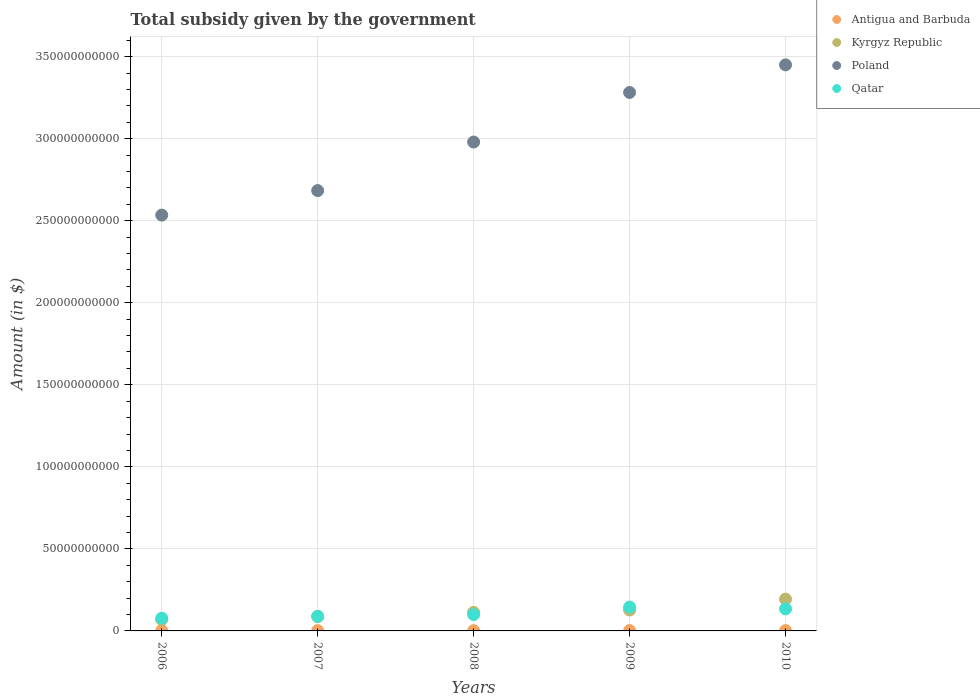How many different coloured dotlines are there?
Your answer should be very brief. 4. Is the number of dotlines equal to the number of legend labels?
Ensure brevity in your answer.  Yes. What is the total revenue collected by the government in Qatar in 2009?
Your answer should be very brief. 1.45e+1. Across all years, what is the maximum total revenue collected by the government in Kyrgyz Republic?
Give a very brief answer. 1.94e+1. Across all years, what is the minimum total revenue collected by the government in Antigua and Barbuda?
Provide a short and direct response. 1.78e+08. In which year was the total revenue collected by the government in Poland maximum?
Your response must be concise. 2010. In which year was the total revenue collected by the government in Qatar minimum?
Provide a succinct answer. 2006. What is the total total revenue collected by the government in Qatar in the graph?
Make the answer very short. 5.46e+1. What is the difference between the total revenue collected by the government in Antigua and Barbuda in 2006 and that in 2010?
Your answer should be compact. -1.39e+07. What is the difference between the total revenue collected by the government in Qatar in 2007 and the total revenue collected by the government in Kyrgyz Republic in 2010?
Make the answer very short. -1.05e+1. What is the average total revenue collected by the government in Qatar per year?
Your answer should be very brief. 1.09e+1. In the year 2009, what is the difference between the total revenue collected by the government in Poland and total revenue collected by the government in Qatar?
Your answer should be very brief. 3.14e+11. In how many years, is the total revenue collected by the government in Kyrgyz Republic greater than 350000000000 $?
Offer a terse response. 0. What is the ratio of the total revenue collected by the government in Antigua and Barbuda in 2006 to that in 2007?
Keep it short and to the point. 1.02. What is the difference between the highest and the second highest total revenue collected by the government in Antigua and Barbuda?
Keep it short and to the point. 1.89e+07. What is the difference between the highest and the lowest total revenue collected by the government in Kyrgyz Republic?
Offer a very short reply. 1.24e+1. Is it the case that in every year, the sum of the total revenue collected by the government in Antigua and Barbuda and total revenue collected by the government in Kyrgyz Republic  is greater than the sum of total revenue collected by the government in Qatar and total revenue collected by the government in Poland?
Your response must be concise. No. Does the total revenue collected by the government in Antigua and Barbuda monotonically increase over the years?
Your response must be concise. No. Is the total revenue collected by the government in Qatar strictly greater than the total revenue collected by the government in Poland over the years?
Keep it short and to the point. No. Is the total revenue collected by the government in Antigua and Barbuda strictly less than the total revenue collected by the government in Qatar over the years?
Offer a very short reply. Yes. How many dotlines are there?
Offer a terse response. 4. What is the difference between two consecutive major ticks on the Y-axis?
Give a very brief answer. 5.00e+1. Where does the legend appear in the graph?
Ensure brevity in your answer.  Top right. How many legend labels are there?
Ensure brevity in your answer.  4. What is the title of the graph?
Give a very brief answer. Total subsidy given by the government. Does "Slovenia" appear as one of the legend labels in the graph?
Make the answer very short. No. What is the label or title of the Y-axis?
Your answer should be very brief. Amount (in $). What is the Amount (in $) in Antigua and Barbuda in 2006?
Your answer should be compact. 1.92e+08. What is the Amount (in $) of Kyrgyz Republic in 2006?
Offer a terse response. 6.97e+09. What is the Amount (in $) in Poland in 2006?
Give a very brief answer. 2.53e+11. What is the Amount (in $) of Qatar in 2006?
Your answer should be very brief. 7.79e+09. What is the Amount (in $) in Antigua and Barbuda in 2007?
Give a very brief answer. 1.88e+08. What is the Amount (in $) of Kyrgyz Republic in 2007?
Your answer should be very brief. 8.72e+09. What is the Amount (in $) in Poland in 2007?
Give a very brief answer. 2.68e+11. What is the Amount (in $) of Qatar in 2007?
Keep it short and to the point. 8.92e+09. What is the Amount (in $) of Antigua and Barbuda in 2008?
Make the answer very short. 1.78e+08. What is the Amount (in $) in Kyrgyz Republic in 2008?
Make the answer very short. 1.13e+1. What is the Amount (in $) of Poland in 2008?
Provide a succinct answer. 2.98e+11. What is the Amount (in $) in Qatar in 2008?
Ensure brevity in your answer.  9.95e+09. What is the Amount (in $) in Antigua and Barbuda in 2009?
Offer a terse response. 2.24e+08. What is the Amount (in $) of Kyrgyz Republic in 2009?
Offer a terse response. 1.28e+1. What is the Amount (in $) in Poland in 2009?
Provide a succinct answer. 3.28e+11. What is the Amount (in $) in Qatar in 2009?
Your response must be concise. 1.45e+1. What is the Amount (in $) in Antigua and Barbuda in 2010?
Ensure brevity in your answer.  2.06e+08. What is the Amount (in $) of Kyrgyz Republic in 2010?
Your answer should be compact. 1.94e+1. What is the Amount (in $) of Poland in 2010?
Make the answer very short. 3.45e+11. What is the Amount (in $) of Qatar in 2010?
Ensure brevity in your answer.  1.34e+1. Across all years, what is the maximum Amount (in $) of Antigua and Barbuda?
Give a very brief answer. 2.24e+08. Across all years, what is the maximum Amount (in $) of Kyrgyz Republic?
Ensure brevity in your answer.  1.94e+1. Across all years, what is the maximum Amount (in $) of Poland?
Offer a terse response. 3.45e+11. Across all years, what is the maximum Amount (in $) of Qatar?
Your response must be concise. 1.45e+1. Across all years, what is the minimum Amount (in $) in Antigua and Barbuda?
Give a very brief answer. 1.78e+08. Across all years, what is the minimum Amount (in $) of Kyrgyz Republic?
Offer a very short reply. 6.97e+09. Across all years, what is the minimum Amount (in $) in Poland?
Keep it short and to the point. 2.53e+11. Across all years, what is the minimum Amount (in $) of Qatar?
Your response must be concise. 7.79e+09. What is the total Amount (in $) in Antigua and Barbuda in the graph?
Ensure brevity in your answer.  9.88e+08. What is the total Amount (in $) in Kyrgyz Republic in the graph?
Provide a succinct answer. 5.91e+1. What is the total Amount (in $) of Poland in the graph?
Your response must be concise. 1.49e+12. What is the total Amount (in $) in Qatar in the graph?
Make the answer very short. 5.46e+1. What is the difference between the Amount (in $) of Antigua and Barbuda in 2006 and that in 2007?
Make the answer very short. 3.10e+06. What is the difference between the Amount (in $) of Kyrgyz Republic in 2006 and that in 2007?
Your answer should be very brief. -1.75e+09. What is the difference between the Amount (in $) of Poland in 2006 and that in 2007?
Provide a short and direct response. -1.49e+1. What is the difference between the Amount (in $) in Qatar in 2006 and that in 2007?
Provide a short and direct response. -1.13e+09. What is the difference between the Amount (in $) in Antigua and Barbuda in 2006 and that in 2008?
Give a very brief answer. 1.32e+07. What is the difference between the Amount (in $) in Kyrgyz Republic in 2006 and that in 2008?
Your answer should be compact. -4.34e+09. What is the difference between the Amount (in $) in Poland in 2006 and that in 2008?
Offer a terse response. -4.45e+1. What is the difference between the Amount (in $) in Qatar in 2006 and that in 2008?
Offer a very short reply. -2.16e+09. What is the difference between the Amount (in $) in Antigua and Barbuda in 2006 and that in 2009?
Your answer should be compact. -3.28e+07. What is the difference between the Amount (in $) in Kyrgyz Republic in 2006 and that in 2009?
Make the answer very short. -5.79e+09. What is the difference between the Amount (in $) of Poland in 2006 and that in 2009?
Ensure brevity in your answer.  -7.47e+1. What is the difference between the Amount (in $) of Qatar in 2006 and that in 2009?
Your response must be concise. -6.75e+09. What is the difference between the Amount (in $) of Antigua and Barbuda in 2006 and that in 2010?
Ensure brevity in your answer.  -1.39e+07. What is the difference between the Amount (in $) of Kyrgyz Republic in 2006 and that in 2010?
Offer a very short reply. -1.24e+1. What is the difference between the Amount (in $) in Poland in 2006 and that in 2010?
Your answer should be very brief. -9.16e+1. What is the difference between the Amount (in $) of Qatar in 2006 and that in 2010?
Make the answer very short. -5.64e+09. What is the difference between the Amount (in $) of Antigua and Barbuda in 2007 and that in 2008?
Your response must be concise. 1.01e+07. What is the difference between the Amount (in $) of Kyrgyz Republic in 2007 and that in 2008?
Ensure brevity in your answer.  -2.58e+09. What is the difference between the Amount (in $) in Poland in 2007 and that in 2008?
Provide a succinct answer. -2.96e+1. What is the difference between the Amount (in $) in Qatar in 2007 and that in 2008?
Your answer should be very brief. -1.03e+09. What is the difference between the Amount (in $) in Antigua and Barbuda in 2007 and that in 2009?
Provide a short and direct response. -3.59e+07. What is the difference between the Amount (in $) in Kyrgyz Republic in 2007 and that in 2009?
Give a very brief answer. -4.04e+09. What is the difference between the Amount (in $) of Poland in 2007 and that in 2009?
Provide a succinct answer. -5.98e+1. What is the difference between the Amount (in $) in Qatar in 2007 and that in 2009?
Your answer should be very brief. -5.62e+09. What is the difference between the Amount (in $) of Antigua and Barbuda in 2007 and that in 2010?
Give a very brief answer. -1.70e+07. What is the difference between the Amount (in $) of Kyrgyz Republic in 2007 and that in 2010?
Your answer should be compact. -1.07e+1. What is the difference between the Amount (in $) of Poland in 2007 and that in 2010?
Offer a very short reply. -7.66e+1. What is the difference between the Amount (in $) in Qatar in 2007 and that in 2010?
Your answer should be very brief. -4.51e+09. What is the difference between the Amount (in $) in Antigua and Barbuda in 2008 and that in 2009?
Provide a short and direct response. -4.60e+07. What is the difference between the Amount (in $) in Kyrgyz Republic in 2008 and that in 2009?
Offer a terse response. -1.46e+09. What is the difference between the Amount (in $) in Poland in 2008 and that in 2009?
Make the answer very short. -3.02e+1. What is the difference between the Amount (in $) in Qatar in 2008 and that in 2009?
Give a very brief answer. -4.59e+09. What is the difference between the Amount (in $) in Antigua and Barbuda in 2008 and that in 2010?
Your answer should be very brief. -2.71e+07. What is the difference between the Amount (in $) of Kyrgyz Republic in 2008 and that in 2010?
Your answer should be very brief. -8.08e+09. What is the difference between the Amount (in $) of Poland in 2008 and that in 2010?
Your response must be concise. -4.70e+1. What is the difference between the Amount (in $) of Qatar in 2008 and that in 2010?
Your response must be concise. -3.48e+09. What is the difference between the Amount (in $) of Antigua and Barbuda in 2009 and that in 2010?
Provide a short and direct response. 1.89e+07. What is the difference between the Amount (in $) of Kyrgyz Republic in 2009 and that in 2010?
Offer a very short reply. -6.62e+09. What is the difference between the Amount (in $) in Poland in 2009 and that in 2010?
Your response must be concise. -1.68e+1. What is the difference between the Amount (in $) in Qatar in 2009 and that in 2010?
Your answer should be very brief. 1.11e+09. What is the difference between the Amount (in $) of Antigua and Barbuda in 2006 and the Amount (in $) of Kyrgyz Republic in 2007?
Offer a very short reply. -8.53e+09. What is the difference between the Amount (in $) in Antigua and Barbuda in 2006 and the Amount (in $) in Poland in 2007?
Ensure brevity in your answer.  -2.68e+11. What is the difference between the Amount (in $) of Antigua and Barbuda in 2006 and the Amount (in $) of Qatar in 2007?
Provide a short and direct response. -8.73e+09. What is the difference between the Amount (in $) of Kyrgyz Republic in 2006 and the Amount (in $) of Poland in 2007?
Your answer should be compact. -2.61e+11. What is the difference between the Amount (in $) of Kyrgyz Republic in 2006 and the Amount (in $) of Qatar in 2007?
Keep it short and to the point. -1.95e+09. What is the difference between the Amount (in $) in Poland in 2006 and the Amount (in $) in Qatar in 2007?
Your response must be concise. 2.44e+11. What is the difference between the Amount (in $) of Antigua and Barbuda in 2006 and the Amount (in $) of Kyrgyz Republic in 2008?
Ensure brevity in your answer.  -1.11e+1. What is the difference between the Amount (in $) in Antigua and Barbuda in 2006 and the Amount (in $) in Poland in 2008?
Your answer should be compact. -2.98e+11. What is the difference between the Amount (in $) in Antigua and Barbuda in 2006 and the Amount (in $) in Qatar in 2008?
Keep it short and to the point. -9.76e+09. What is the difference between the Amount (in $) of Kyrgyz Republic in 2006 and the Amount (in $) of Poland in 2008?
Provide a short and direct response. -2.91e+11. What is the difference between the Amount (in $) in Kyrgyz Republic in 2006 and the Amount (in $) in Qatar in 2008?
Your answer should be compact. -2.99e+09. What is the difference between the Amount (in $) in Poland in 2006 and the Amount (in $) in Qatar in 2008?
Your answer should be compact. 2.43e+11. What is the difference between the Amount (in $) in Antigua and Barbuda in 2006 and the Amount (in $) in Kyrgyz Republic in 2009?
Your response must be concise. -1.26e+1. What is the difference between the Amount (in $) of Antigua and Barbuda in 2006 and the Amount (in $) of Poland in 2009?
Offer a very short reply. -3.28e+11. What is the difference between the Amount (in $) in Antigua and Barbuda in 2006 and the Amount (in $) in Qatar in 2009?
Ensure brevity in your answer.  -1.43e+1. What is the difference between the Amount (in $) of Kyrgyz Republic in 2006 and the Amount (in $) of Poland in 2009?
Give a very brief answer. -3.21e+11. What is the difference between the Amount (in $) in Kyrgyz Republic in 2006 and the Amount (in $) in Qatar in 2009?
Provide a short and direct response. -7.57e+09. What is the difference between the Amount (in $) in Poland in 2006 and the Amount (in $) in Qatar in 2009?
Make the answer very short. 2.39e+11. What is the difference between the Amount (in $) of Antigua and Barbuda in 2006 and the Amount (in $) of Kyrgyz Republic in 2010?
Make the answer very short. -1.92e+1. What is the difference between the Amount (in $) in Antigua and Barbuda in 2006 and the Amount (in $) in Poland in 2010?
Give a very brief answer. -3.45e+11. What is the difference between the Amount (in $) in Antigua and Barbuda in 2006 and the Amount (in $) in Qatar in 2010?
Offer a terse response. -1.32e+1. What is the difference between the Amount (in $) in Kyrgyz Republic in 2006 and the Amount (in $) in Poland in 2010?
Provide a succinct answer. -3.38e+11. What is the difference between the Amount (in $) of Kyrgyz Republic in 2006 and the Amount (in $) of Qatar in 2010?
Your answer should be very brief. -6.47e+09. What is the difference between the Amount (in $) in Poland in 2006 and the Amount (in $) in Qatar in 2010?
Your answer should be very brief. 2.40e+11. What is the difference between the Amount (in $) in Antigua and Barbuda in 2007 and the Amount (in $) in Kyrgyz Republic in 2008?
Your answer should be compact. -1.11e+1. What is the difference between the Amount (in $) of Antigua and Barbuda in 2007 and the Amount (in $) of Poland in 2008?
Provide a short and direct response. -2.98e+11. What is the difference between the Amount (in $) of Antigua and Barbuda in 2007 and the Amount (in $) of Qatar in 2008?
Give a very brief answer. -9.77e+09. What is the difference between the Amount (in $) in Kyrgyz Republic in 2007 and the Amount (in $) in Poland in 2008?
Your answer should be very brief. -2.89e+11. What is the difference between the Amount (in $) of Kyrgyz Republic in 2007 and the Amount (in $) of Qatar in 2008?
Your answer should be compact. -1.23e+09. What is the difference between the Amount (in $) in Poland in 2007 and the Amount (in $) in Qatar in 2008?
Keep it short and to the point. 2.58e+11. What is the difference between the Amount (in $) in Antigua and Barbuda in 2007 and the Amount (in $) in Kyrgyz Republic in 2009?
Offer a very short reply. -1.26e+1. What is the difference between the Amount (in $) of Antigua and Barbuda in 2007 and the Amount (in $) of Poland in 2009?
Make the answer very short. -3.28e+11. What is the difference between the Amount (in $) of Antigua and Barbuda in 2007 and the Amount (in $) of Qatar in 2009?
Give a very brief answer. -1.44e+1. What is the difference between the Amount (in $) of Kyrgyz Republic in 2007 and the Amount (in $) of Poland in 2009?
Your response must be concise. -3.19e+11. What is the difference between the Amount (in $) in Kyrgyz Republic in 2007 and the Amount (in $) in Qatar in 2009?
Offer a terse response. -5.82e+09. What is the difference between the Amount (in $) of Poland in 2007 and the Amount (in $) of Qatar in 2009?
Your answer should be compact. 2.54e+11. What is the difference between the Amount (in $) in Antigua and Barbuda in 2007 and the Amount (in $) in Kyrgyz Republic in 2010?
Offer a very short reply. -1.92e+1. What is the difference between the Amount (in $) in Antigua and Barbuda in 2007 and the Amount (in $) in Poland in 2010?
Offer a very short reply. -3.45e+11. What is the difference between the Amount (in $) in Antigua and Barbuda in 2007 and the Amount (in $) in Qatar in 2010?
Make the answer very short. -1.32e+1. What is the difference between the Amount (in $) in Kyrgyz Republic in 2007 and the Amount (in $) in Poland in 2010?
Offer a terse response. -3.36e+11. What is the difference between the Amount (in $) in Kyrgyz Republic in 2007 and the Amount (in $) in Qatar in 2010?
Your answer should be very brief. -4.71e+09. What is the difference between the Amount (in $) in Poland in 2007 and the Amount (in $) in Qatar in 2010?
Make the answer very short. 2.55e+11. What is the difference between the Amount (in $) of Antigua and Barbuda in 2008 and the Amount (in $) of Kyrgyz Republic in 2009?
Offer a terse response. -1.26e+1. What is the difference between the Amount (in $) in Antigua and Barbuda in 2008 and the Amount (in $) in Poland in 2009?
Your response must be concise. -3.28e+11. What is the difference between the Amount (in $) of Antigua and Barbuda in 2008 and the Amount (in $) of Qatar in 2009?
Keep it short and to the point. -1.44e+1. What is the difference between the Amount (in $) of Kyrgyz Republic in 2008 and the Amount (in $) of Poland in 2009?
Give a very brief answer. -3.17e+11. What is the difference between the Amount (in $) of Kyrgyz Republic in 2008 and the Amount (in $) of Qatar in 2009?
Your response must be concise. -3.24e+09. What is the difference between the Amount (in $) of Poland in 2008 and the Amount (in $) of Qatar in 2009?
Keep it short and to the point. 2.83e+11. What is the difference between the Amount (in $) of Antigua and Barbuda in 2008 and the Amount (in $) of Kyrgyz Republic in 2010?
Make the answer very short. -1.92e+1. What is the difference between the Amount (in $) of Antigua and Barbuda in 2008 and the Amount (in $) of Poland in 2010?
Make the answer very short. -3.45e+11. What is the difference between the Amount (in $) of Antigua and Barbuda in 2008 and the Amount (in $) of Qatar in 2010?
Your response must be concise. -1.33e+1. What is the difference between the Amount (in $) in Kyrgyz Republic in 2008 and the Amount (in $) in Poland in 2010?
Provide a short and direct response. -3.34e+11. What is the difference between the Amount (in $) in Kyrgyz Republic in 2008 and the Amount (in $) in Qatar in 2010?
Your response must be concise. -2.13e+09. What is the difference between the Amount (in $) of Poland in 2008 and the Amount (in $) of Qatar in 2010?
Provide a succinct answer. 2.85e+11. What is the difference between the Amount (in $) of Antigua and Barbuda in 2009 and the Amount (in $) of Kyrgyz Republic in 2010?
Provide a short and direct response. -1.92e+1. What is the difference between the Amount (in $) of Antigua and Barbuda in 2009 and the Amount (in $) of Poland in 2010?
Your response must be concise. -3.45e+11. What is the difference between the Amount (in $) in Antigua and Barbuda in 2009 and the Amount (in $) in Qatar in 2010?
Ensure brevity in your answer.  -1.32e+1. What is the difference between the Amount (in $) in Kyrgyz Republic in 2009 and the Amount (in $) in Poland in 2010?
Your response must be concise. -3.32e+11. What is the difference between the Amount (in $) in Kyrgyz Republic in 2009 and the Amount (in $) in Qatar in 2010?
Provide a succinct answer. -6.71e+08. What is the difference between the Amount (in $) in Poland in 2009 and the Amount (in $) in Qatar in 2010?
Keep it short and to the point. 3.15e+11. What is the average Amount (in $) in Antigua and Barbuda per year?
Give a very brief answer. 1.98e+08. What is the average Amount (in $) of Kyrgyz Republic per year?
Ensure brevity in your answer.  1.18e+1. What is the average Amount (in $) of Poland per year?
Keep it short and to the point. 2.99e+11. What is the average Amount (in $) of Qatar per year?
Your answer should be compact. 1.09e+1. In the year 2006, what is the difference between the Amount (in $) of Antigua and Barbuda and Amount (in $) of Kyrgyz Republic?
Make the answer very short. -6.77e+09. In the year 2006, what is the difference between the Amount (in $) of Antigua and Barbuda and Amount (in $) of Poland?
Keep it short and to the point. -2.53e+11. In the year 2006, what is the difference between the Amount (in $) in Antigua and Barbuda and Amount (in $) in Qatar?
Offer a very short reply. -7.60e+09. In the year 2006, what is the difference between the Amount (in $) of Kyrgyz Republic and Amount (in $) of Poland?
Provide a short and direct response. -2.46e+11. In the year 2006, what is the difference between the Amount (in $) in Kyrgyz Republic and Amount (in $) in Qatar?
Your answer should be compact. -8.22e+08. In the year 2006, what is the difference between the Amount (in $) in Poland and Amount (in $) in Qatar?
Provide a succinct answer. 2.46e+11. In the year 2007, what is the difference between the Amount (in $) in Antigua and Barbuda and Amount (in $) in Kyrgyz Republic?
Your answer should be very brief. -8.53e+09. In the year 2007, what is the difference between the Amount (in $) in Antigua and Barbuda and Amount (in $) in Poland?
Your response must be concise. -2.68e+11. In the year 2007, what is the difference between the Amount (in $) in Antigua and Barbuda and Amount (in $) in Qatar?
Offer a very short reply. -8.73e+09. In the year 2007, what is the difference between the Amount (in $) of Kyrgyz Republic and Amount (in $) of Poland?
Provide a succinct answer. -2.60e+11. In the year 2007, what is the difference between the Amount (in $) of Kyrgyz Republic and Amount (in $) of Qatar?
Offer a very short reply. -2.00e+08. In the year 2007, what is the difference between the Amount (in $) of Poland and Amount (in $) of Qatar?
Your response must be concise. 2.59e+11. In the year 2008, what is the difference between the Amount (in $) of Antigua and Barbuda and Amount (in $) of Kyrgyz Republic?
Provide a short and direct response. -1.11e+1. In the year 2008, what is the difference between the Amount (in $) in Antigua and Barbuda and Amount (in $) in Poland?
Provide a succinct answer. -2.98e+11. In the year 2008, what is the difference between the Amount (in $) in Antigua and Barbuda and Amount (in $) in Qatar?
Give a very brief answer. -9.78e+09. In the year 2008, what is the difference between the Amount (in $) of Kyrgyz Republic and Amount (in $) of Poland?
Your response must be concise. -2.87e+11. In the year 2008, what is the difference between the Amount (in $) of Kyrgyz Republic and Amount (in $) of Qatar?
Offer a terse response. 1.35e+09. In the year 2008, what is the difference between the Amount (in $) of Poland and Amount (in $) of Qatar?
Ensure brevity in your answer.  2.88e+11. In the year 2009, what is the difference between the Amount (in $) of Antigua and Barbuda and Amount (in $) of Kyrgyz Republic?
Keep it short and to the point. -1.25e+1. In the year 2009, what is the difference between the Amount (in $) in Antigua and Barbuda and Amount (in $) in Poland?
Provide a short and direct response. -3.28e+11. In the year 2009, what is the difference between the Amount (in $) in Antigua and Barbuda and Amount (in $) in Qatar?
Provide a succinct answer. -1.43e+1. In the year 2009, what is the difference between the Amount (in $) of Kyrgyz Republic and Amount (in $) of Poland?
Provide a short and direct response. -3.15e+11. In the year 2009, what is the difference between the Amount (in $) in Kyrgyz Republic and Amount (in $) in Qatar?
Make the answer very short. -1.78e+09. In the year 2009, what is the difference between the Amount (in $) in Poland and Amount (in $) in Qatar?
Your answer should be compact. 3.14e+11. In the year 2010, what is the difference between the Amount (in $) in Antigua and Barbuda and Amount (in $) in Kyrgyz Republic?
Keep it short and to the point. -1.92e+1. In the year 2010, what is the difference between the Amount (in $) in Antigua and Barbuda and Amount (in $) in Poland?
Your answer should be very brief. -3.45e+11. In the year 2010, what is the difference between the Amount (in $) of Antigua and Barbuda and Amount (in $) of Qatar?
Your answer should be very brief. -1.32e+1. In the year 2010, what is the difference between the Amount (in $) of Kyrgyz Republic and Amount (in $) of Poland?
Keep it short and to the point. -3.26e+11. In the year 2010, what is the difference between the Amount (in $) in Kyrgyz Republic and Amount (in $) in Qatar?
Your response must be concise. 5.95e+09. In the year 2010, what is the difference between the Amount (in $) in Poland and Amount (in $) in Qatar?
Ensure brevity in your answer.  3.32e+11. What is the ratio of the Amount (in $) in Antigua and Barbuda in 2006 to that in 2007?
Offer a very short reply. 1.02. What is the ratio of the Amount (in $) in Kyrgyz Republic in 2006 to that in 2007?
Your response must be concise. 0.8. What is the ratio of the Amount (in $) of Poland in 2006 to that in 2007?
Offer a terse response. 0.94. What is the ratio of the Amount (in $) of Qatar in 2006 to that in 2007?
Your answer should be very brief. 0.87. What is the ratio of the Amount (in $) of Antigua and Barbuda in 2006 to that in 2008?
Provide a short and direct response. 1.07. What is the ratio of the Amount (in $) of Kyrgyz Republic in 2006 to that in 2008?
Your response must be concise. 0.62. What is the ratio of the Amount (in $) of Poland in 2006 to that in 2008?
Give a very brief answer. 0.85. What is the ratio of the Amount (in $) of Qatar in 2006 to that in 2008?
Provide a short and direct response. 0.78. What is the ratio of the Amount (in $) in Antigua and Barbuda in 2006 to that in 2009?
Your response must be concise. 0.85. What is the ratio of the Amount (in $) of Kyrgyz Republic in 2006 to that in 2009?
Offer a terse response. 0.55. What is the ratio of the Amount (in $) of Poland in 2006 to that in 2009?
Ensure brevity in your answer.  0.77. What is the ratio of the Amount (in $) of Qatar in 2006 to that in 2009?
Your response must be concise. 0.54. What is the ratio of the Amount (in $) in Antigua and Barbuda in 2006 to that in 2010?
Keep it short and to the point. 0.93. What is the ratio of the Amount (in $) of Kyrgyz Republic in 2006 to that in 2010?
Ensure brevity in your answer.  0.36. What is the ratio of the Amount (in $) of Poland in 2006 to that in 2010?
Offer a terse response. 0.73. What is the ratio of the Amount (in $) in Qatar in 2006 to that in 2010?
Ensure brevity in your answer.  0.58. What is the ratio of the Amount (in $) of Antigua and Barbuda in 2007 to that in 2008?
Give a very brief answer. 1.06. What is the ratio of the Amount (in $) of Kyrgyz Republic in 2007 to that in 2008?
Your answer should be compact. 0.77. What is the ratio of the Amount (in $) in Poland in 2007 to that in 2008?
Your response must be concise. 0.9. What is the ratio of the Amount (in $) of Qatar in 2007 to that in 2008?
Keep it short and to the point. 0.9. What is the ratio of the Amount (in $) in Antigua and Barbuda in 2007 to that in 2009?
Make the answer very short. 0.84. What is the ratio of the Amount (in $) of Kyrgyz Republic in 2007 to that in 2009?
Your response must be concise. 0.68. What is the ratio of the Amount (in $) in Poland in 2007 to that in 2009?
Keep it short and to the point. 0.82. What is the ratio of the Amount (in $) in Qatar in 2007 to that in 2009?
Provide a short and direct response. 0.61. What is the ratio of the Amount (in $) of Antigua and Barbuda in 2007 to that in 2010?
Your response must be concise. 0.92. What is the ratio of the Amount (in $) of Kyrgyz Republic in 2007 to that in 2010?
Make the answer very short. 0.45. What is the ratio of the Amount (in $) of Poland in 2007 to that in 2010?
Offer a very short reply. 0.78. What is the ratio of the Amount (in $) of Qatar in 2007 to that in 2010?
Keep it short and to the point. 0.66. What is the ratio of the Amount (in $) of Antigua and Barbuda in 2008 to that in 2009?
Keep it short and to the point. 0.8. What is the ratio of the Amount (in $) of Kyrgyz Republic in 2008 to that in 2009?
Provide a short and direct response. 0.89. What is the ratio of the Amount (in $) of Poland in 2008 to that in 2009?
Ensure brevity in your answer.  0.91. What is the ratio of the Amount (in $) in Qatar in 2008 to that in 2009?
Provide a short and direct response. 0.68. What is the ratio of the Amount (in $) in Antigua and Barbuda in 2008 to that in 2010?
Ensure brevity in your answer.  0.87. What is the ratio of the Amount (in $) in Kyrgyz Republic in 2008 to that in 2010?
Make the answer very short. 0.58. What is the ratio of the Amount (in $) of Poland in 2008 to that in 2010?
Your answer should be very brief. 0.86. What is the ratio of the Amount (in $) in Qatar in 2008 to that in 2010?
Your answer should be compact. 0.74. What is the ratio of the Amount (in $) in Antigua and Barbuda in 2009 to that in 2010?
Your answer should be very brief. 1.09. What is the ratio of the Amount (in $) of Kyrgyz Republic in 2009 to that in 2010?
Your answer should be very brief. 0.66. What is the ratio of the Amount (in $) of Poland in 2009 to that in 2010?
Provide a short and direct response. 0.95. What is the ratio of the Amount (in $) in Qatar in 2009 to that in 2010?
Your answer should be very brief. 1.08. What is the difference between the highest and the second highest Amount (in $) of Antigua and Barbuda?
Offer a terse response. 1.89e+07. What is the difference between the highest and the second highest Amount (in $) of Kyrgyz Republic?
Your answer should be compact. 6.62e+09. What is the difference between the highest and the second highest Amount (in $) of Poland?
Give a very brief answer. 1.68e+1. What is the difference between the highest and the second highest Amount (in $) in Qatar?
Your answer should be very brief. 1.11e+09. What is the difference between the highest and the lowest Amount (in $) of Antigua and Barbuda?
Ensure brevity in your answer.  4.60e+07. What is the difference between the highest and the lowest Amount (in $) in Kyrgyz Republic?
Provide a succinct answer. 1.24e+1. What is the difference between the highest and the lowest Amount (in $) in Poland?
Your response must be concise. 9.16e+1. What is the difference between the highest and the lowest Amount (in $) in Qatar?
Give a very brief answer. 6.75e+09. 